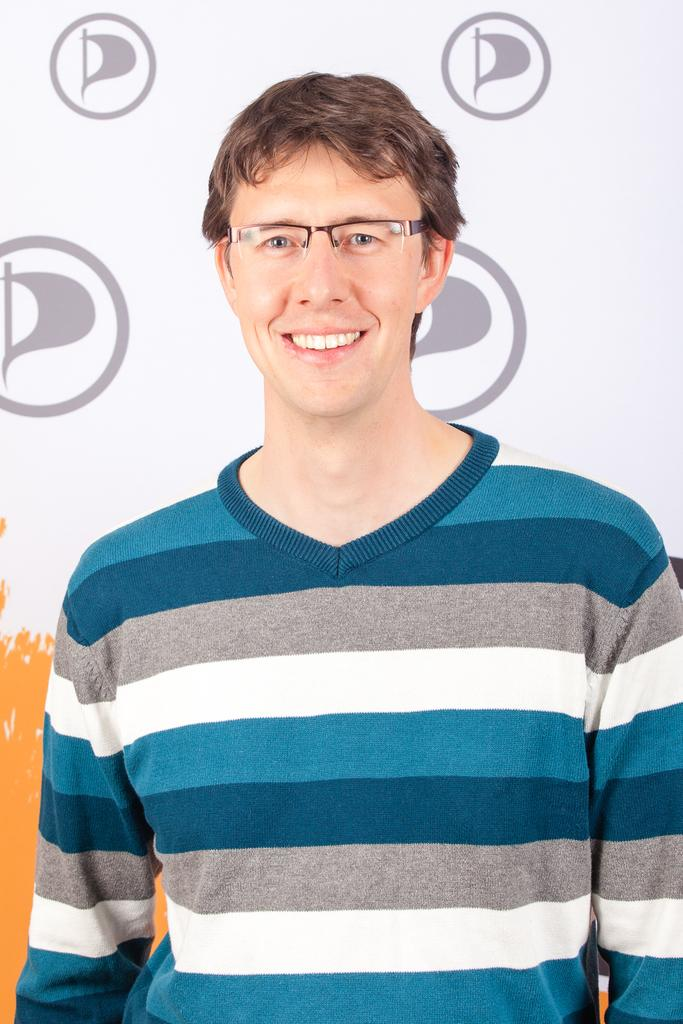What can be seen in the image? There is a person in the image. How is the person's facial expression? The person is smiling. What accessory is the person wearing? The person is wearing spectacles. What is visible in the background of the image? There is a wall in the background of the image. What type of stocking is the person wearing in the image? There is no mention of stockings in the image, so it cannot be determined if the person is wearing any. 